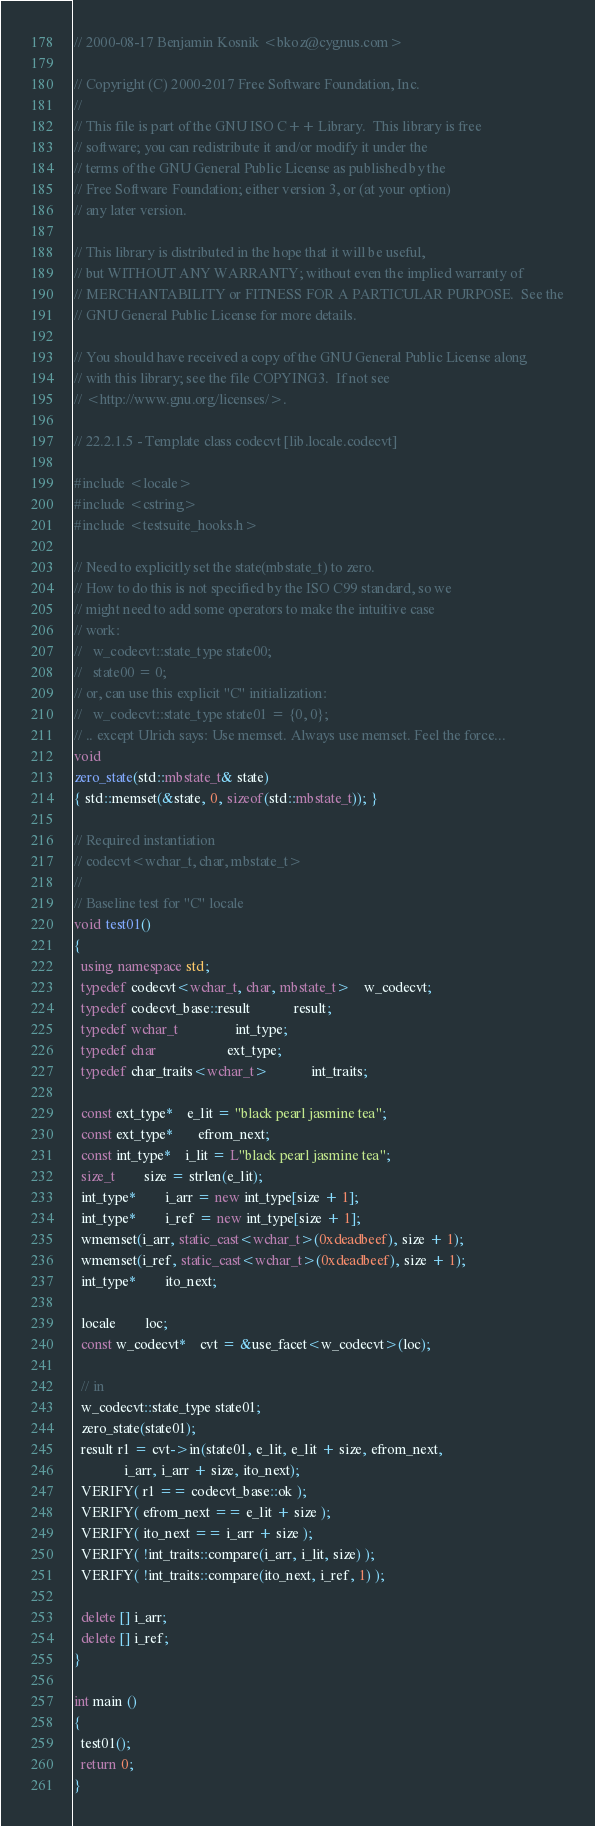<code> <loc_0><loc_0><loc_500><loc_500><_C++_>// 2000-08-17 Benjamin Kosnik <bkoz@cygnus.com>

// Copyright (C) 2000-2017 Free Software Foundation, Inc.
//
// This file is part of the GNU ISO C++ Library.  This library is free
// software; you can redistribute it and/or modify it under the
// terms of the GNU General Public License as published by the
// Free Software Foundation; either version 3, or (at your option)
// any later version.

// This library is distributed in the hope that it will be useful,
// but WITHOUT ANY WARRANTY; without even the implied warranty of
// MERCHANTABILITY or FITNESS FOR A PARTICULAR PURPOSE.  See the
// GNU General Public License for more details.

// You should have received a copy of the GNU General Public License along
// with this library; see the file COPYING3.  If not see
// <http://www.gnu.org/licenses/>.

// 22.2.1.5 - Template class codecvt [lib.locale.codecvt]

#include <locale>
#include <cstring>
#include <testsuite_hooks.h>

// Need to explicitly set the state(mbstate_t) to zero.
// How to do this is not specified by the ISO C99 standard, so we
// might need to add some operators to make the intuitive case
// work:
//   w_codecvt::state_type state00;
//   state00 = 0;  
// or, can use this explicit "C" initialization:
//   w_codecvt::state_type state01 = {0, 0};
// .. except Ulrich says: Use memset. Always use memset. Feel the force...
void
zero_state(std::mbstate_t& state)
{ std::memset(&state, 0, sizeof(std::mbstate_t)); }

// Required instantiation
// codecvt<wchar_t, char, mbstate_t>
//
// Baseline test for "C" locale
void test01()
{
  using namespace std;
  typedef codecvt<wchar_t, char, mbstate_t> 	w_codecvt;
  typedef codecvt_base::result			result;
  typedef wchar_t				int_type;
  typedef char					ext_type;
  typedef char_traits<wchar_t>			int_traits;

  const ext_type* 	e_lit = "black pearl jasmine tea";
  const ext_type*       efrom_next;
  const int_type* 	i_lit = L"black pearl jasmine tea";
  size_t 		size = strlen(e_lit);
  int_type* 		i_arr = new int_type[size + 1];
  int_type* 		i_ref = new int_type[size + 1];
  wmemset(i_arr, static_cast<wchar_t>(0xdeadbeef), size + 1);
  wmemset(i_ref, static_cast<wchar_t>(0xdeadbeef), size + 1);
  int_type*		ito_next;

  locale 		loc;
  const w_codecvt* 	cvt = &use_facet<w_codecvt>(loc); 

  // in
  w_codecvt::state_type state01;
  zero_state(state01);
  result r1 = cvt->in(state01, e_lit, e_lit + size, efrom_next, 
		      i_arr, i_arr + size, ito_next);
  VERIFY( r1 == codecvt_base::ok );
  VERIFY( efrom_next == e_lit + size );
  VERIFY( ito_next == i_arr + size );
  VERIFY( !int_traits::compare(i_arr, i_lit, size) ); 
  VERIFY( !int_traits::compare(ito_next, i_ref, 1) );

  delete [] i_arr;
  delete [] i_ref;
}

int main ()
{
  test01();
  return 0;
}
</code> 